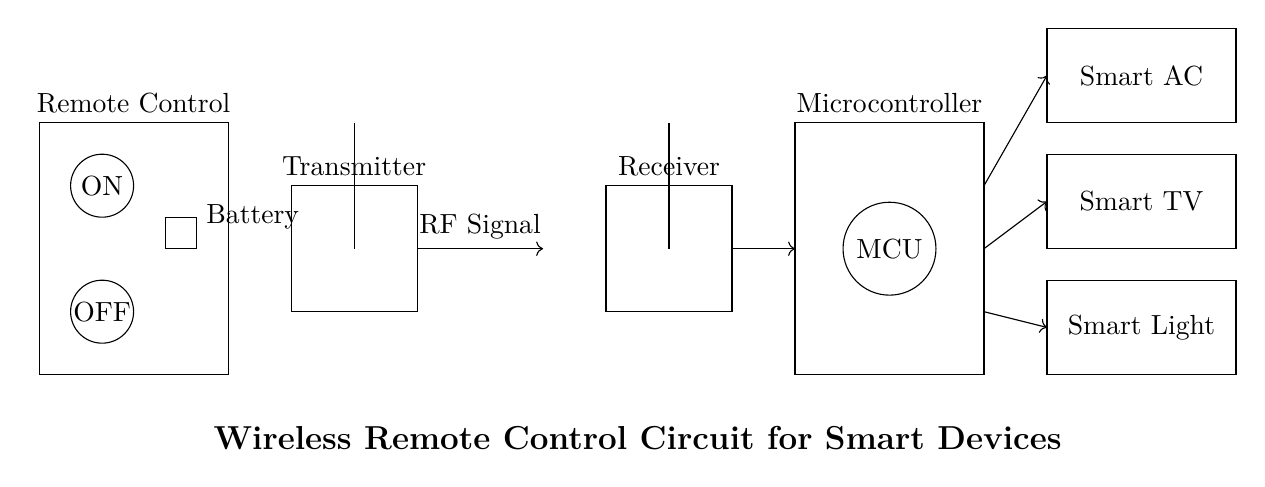What is the main power source for the remote control? The main power source for the remote control is the battery, which is represented in the diagram by the rectangle labeled "Battery."
Answer: Battery How many smart devices are controlled by this circuit? There are three smart devices connected to the microcontroller, which include a smart light, a smart TV, and a smart AC, as shown in the diagram with their respective labels.
Answer: Three What type of signal is transmitted wirelessly? The diagram specifies that the type of signal being transmitted wirelessly is an RF signal, indicated by the label next to the arrow showing the transmission direction.
Answer: RF signal Which component acts as the intermediary between the remote control and the smart devices? The microcontroller serves as the intermediary, as it receives signals from the receiver and sends commands to the connected smart devices. This is clear from the connections depicted in the diagram.
Answer: Microcontroller Where does the wireless signal originate? The wireless signal originates from the transmitter, as shown by the diagram's arrow leading from the transmitter's antenna to the receiver's antenna, which indicates the direction of the signal flow.
Answer: Transmitter What is the function of the receiver in this circuit? The receiver's function is to capture the RF signals sent by the transmitter, which is vital for the communication between the remote control and the smart devices. This is indicated by the connection leading to the microcontroller.
Answer: Capture RF signals 